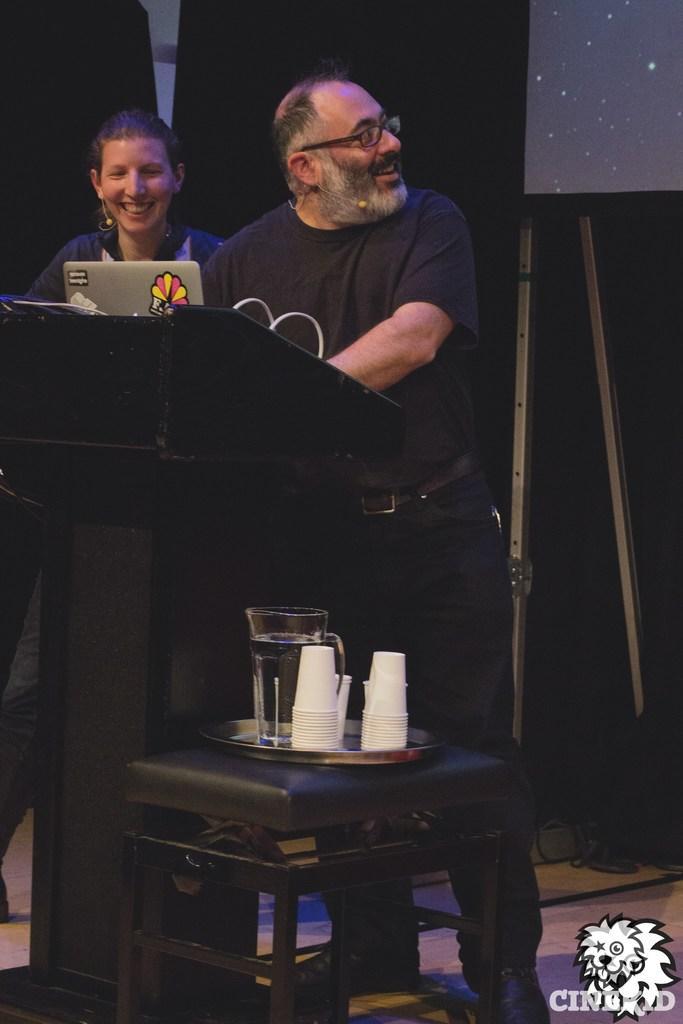Please provide a concise description of this image. In this image there are two people standing on the floor and they are having a smile on their faces. In front of them there is a podium. On top of it there is a laptop. Behind them there is a screen and there are boards. There is a chair. On top of it there are cups and some other objects. There are some text and watermark at the bottom of the image. 